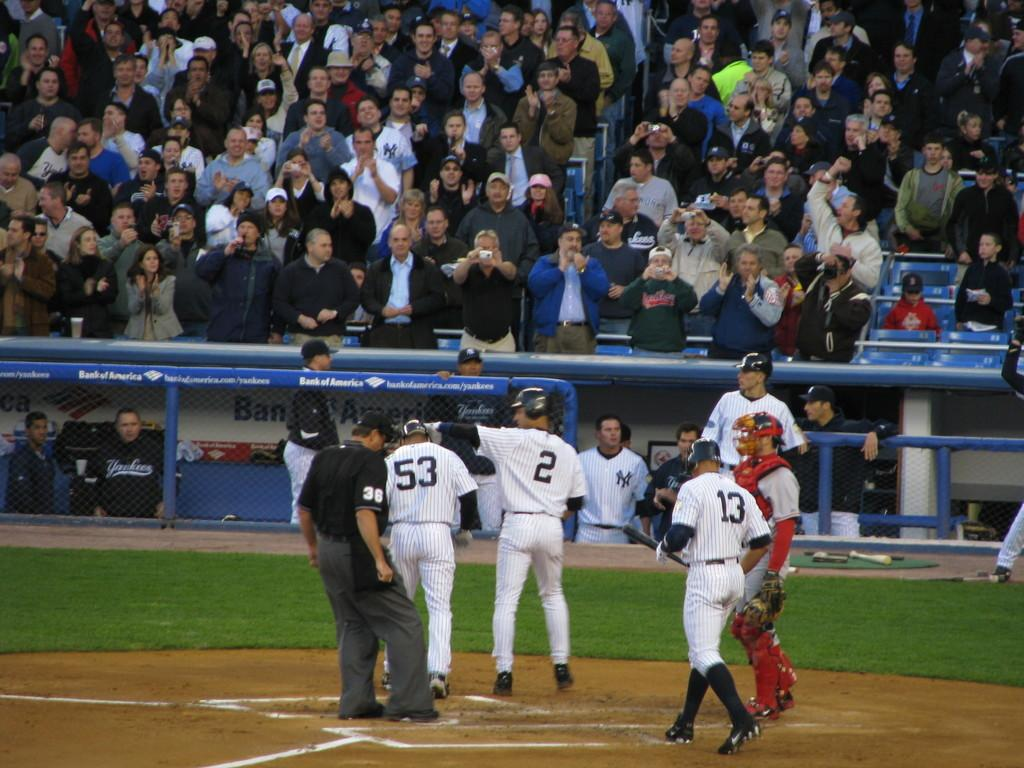Provide a one-sentence caption for the provided image. ny players  53, 2 13 at home base seem in good spirits in front of crowd in stands. 